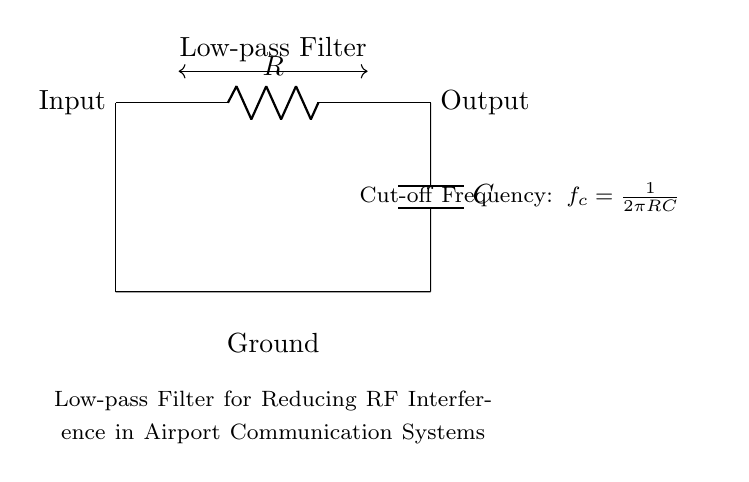What components are used in this circuit? The circuit includes a resistor and a capacitor, which are essential components of a low-pass filter. The resistor is labeled as "R" and the capacitor as "C" in the diagram.
Answer: Resistor and capacitor What is the function of this circuit? The circuit is designed to reduce radio frequency interference, allowing lower frequency signals to pass through while attenuating higher frequency signals. This is essential for maintaining clear communication in airport systems.
Answer: Low-pass filter What is the connection type between the resistor and capacitor? The resistor and capacitor are connected in series, meaning the current flows through the resistor first before reaching the capacitor. This arrangement is critical for the operation of the low-pass filter.
Answer: Series What does the term "cut-off frequency" refer to in this circuit? The cut-off frequency is the point at which the output signal is reduced to 70.7% of the input signal, marking the transition between the passband and the stopband of the filter. It is calculated using the formula provided in the diagram.
Answer: Transition frequency What is the cut-off frequency formula given in the circuit? The cut-off frequency formula is \( f_c = \frac{1}{2\pi RC} \). This shows how the frequency depends on the values of both the resistor and capacitor in the circuit.
Answer: One over two pi RC How does increasing the resistance affect the cut-off frequency? Increasing the resistance will decrease the cut-off frequency because according to the formula \( f_c = \frac{1}{2\pi RC} \), a larger value of R results in a smaller value of \( f_c \), allowing less frequency to pass through.
Answer: Decreases What does the term "ground" indicate in this circuit diagram? The term "ground" in the circuit signifies a reference point for voltage and a common return path for current, ensuring stable operation in the circuit. It is an important part of the circuit for safety and functionality.
Answer: Reference point 